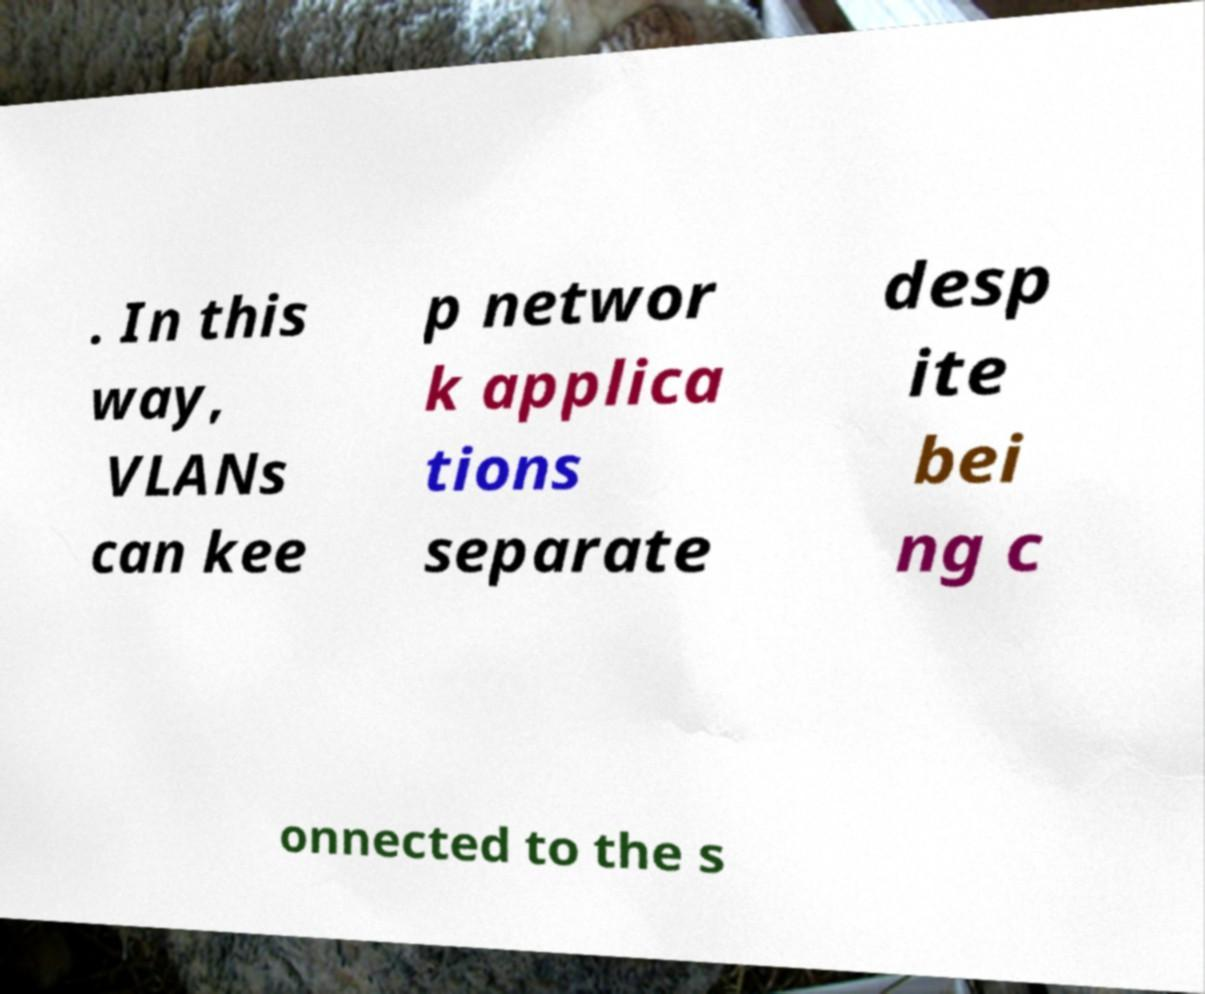Could you extract and type out the text from this image? . In this way, VLANs can kee p networ k applica tions separate desp ite bei ng c onnected to the s 